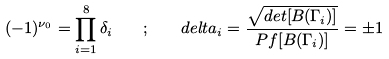<formula> <loc_0><loc_0><loc_500><loc_500>( - 1 ) ^ { \nu _ { 0 } } = \prod _ { i = 1 } ^ { 8 } \delta _ { i } \quad ; \quad d e l t a _ { i } = \frac { \sqrt { d e t [ B ( \Gamma _ { i } ) ] } } { P f [ B ( \Gamma _ { i } ) ] } = \pm 1</formula> 